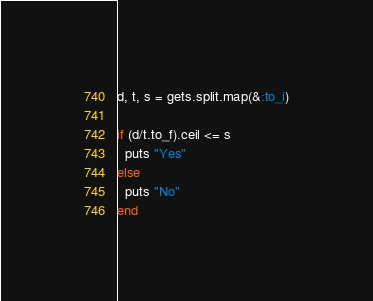<code> <loc_0><loc_0><loc_500><loc_500><_Ruby_>d, t, s = gets.split.map(&:to_i)

if (d/t.to_f).ceil <= s
  puts "Yes"
else
  puts "No"
end</code> 